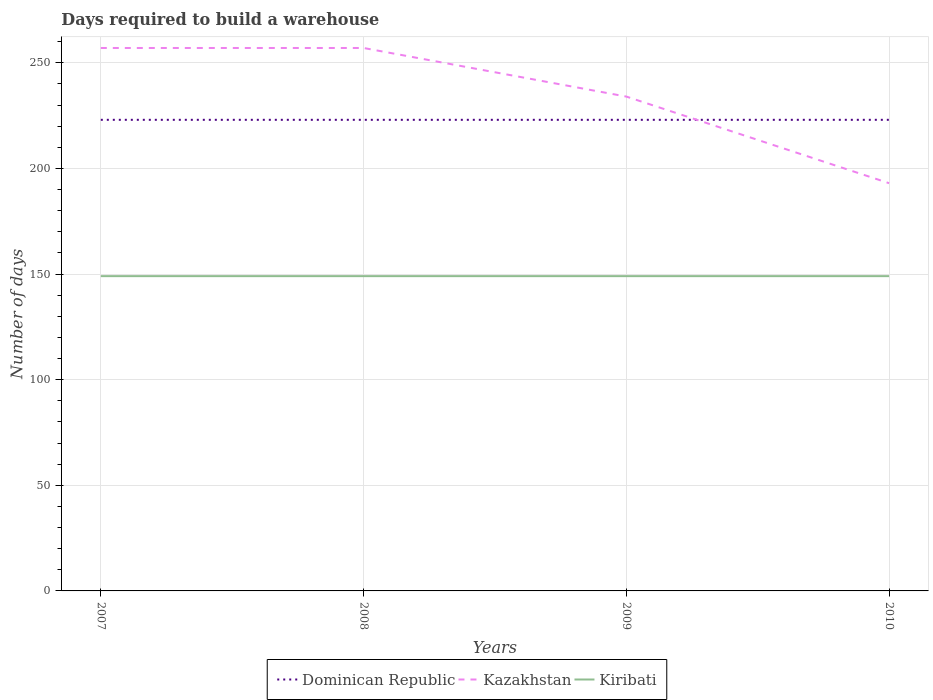Is the number of lines equal to the number of legend labels?
Provide a short and direct response. Yes. Across all years, what is the maximum days required to build a warehouse in in Kiribati?
Your answer should be compact. 149. In which year was the days required to build a warehouse in in Kazakhstan maximum?
Your answer should be compact. 2010. What is the total days required to build a warehouse in in Dominican Republic in the graph?
Your response must be concise. 0. What is the difference between the highest and the second highest days required to build a warehouse in in Kiribati?
Make the answer very short. 0. How many lines are there?
Offer a very short reply. 3. How many years are there in the graph?
Keep it short and to the point. 4. Does the graph contain grids?
Ensure brevity in your answer.  Yes. Where does the legend appear in the graph?
Provide a short and direct response. Bottom center. What is the title of the graph?
Your answer should be compact. Days required to build a warehouse. Does "Macao" appear as one of the legend labels in the graph?
Offer a terse response. No. What is the label or title of the X-axis?
Your answer should be very brief. Years. What is the label or title of the Y-axis?
Your answer should be compact. Number of days. What is the Number of days of Dominican Republic in 2007?
Provide a succinct answer. 223. What is the Number of days in Kazakhstan in 2007?
Your answer should be very brief. 257. What is the Number of days in Kiribati in 2007?
Your response must be concise. 149. What is the Number of days of Dominican Republic in 2008?
Provide a succinct answer. 223. What is the Number of days in Kazakhstan in 2008?
Give a very brief answer. 257. What is the Number of days in Kiribati in 2008?
Give a very brief answer. 149. What is the Number of days of Dominican Republic in 2009?
Give a very brief answer. 223. What is the Number of days in Kazakhstan in 2009?
Offer a very short reply. 234. What is the Number of days in Kiribati in 2009?
Provide a succinct answer. 149. What is the Number of days in Dominican Republic in 2010?
Make the answer very short. 223. What is the Number of days of Kazakhstan in 2010?
Provide a short and direct response. 193. What is the Number of days of Kiribati in 2010?
Provide a succinct answer. 149. Across all years, what is the maximum Number of days in Dominican Republic?
Your answer should be compact. 223. Across all years, what is the maximum Number of days of Kazakhstan?
Your answer should be very brief. 257. Across all years, what is the maximum Number of days in Kiribati?
Make the answer very short. 149. Across all years, what is the minimum Number of days of Dominican Republic?
Keep it short and to the point. 223. Across all years, what is the minimum Number of days of Kazakhstan?
Ensure brevity in your answer.  193. Across all years, what is the minimum Number of days of Kiribati?
Provide a succinct answer. 149. What is the total Number of days in Dominican Republic in the graph?
Provide a short and direct response. 892. What is the total Number of days of Kazakhstan in the graph?
Give a very brief answer. 941. What is the total Number of days in Kiribati in the graph?
Provide a short and direct response. 596. What is the difference between the Number of days of Dominican Republic in 2007 and that in 2008?
Provide a succinct answer. 0. What is the difference between the Number of days in Kazakhstan in 2007 and that in 2008?
Provide a succinct answer. 0. What is the difference between the Number of days in Kiribati in 2007 and that in 2008?
Your answer should be compact. 0. What is the difference between the Number of days of Dominican Republic in 2007 and that in 2009?
Your response must be concise. 0. What is the difference between the Number of days in Kiribati in 2007 and that in 2009?
Your answer should be compact. 0. What is the difference between the Number of days in Dominican Republic in 2008 and that in 2009?
Provide a short and direct response. 0. What is the difference between the Number of days of Kazakhstan in 2008 and that in 2009?
Keep it short and to the point. 23. What is the difference between the Number of days of Kazakhstan in 2008 and that in 2010?
Provide a short and direct response. 64. What is the difference between the Number of days of Dominican Republic in 2009 and that in 2010?
Give a very brief answer. 0. What is the difference between the Number of days of Kazakhstan in 2009 and that in 2010?
Offer a terse response. 41. What is the difference between the Number of days of Kiribati in 2009 and that in 2010?
Give a very brief answer. 0. What is the difference between the Number of days in Dominican Republic in 2007 and the Number of days in Kazakhstan in 2008?
Give a very brief answer. -34. What is the difference between the Number of days of Kazakhstan in 2007 and the Number of days of Kiribati in 2008?
Provide a short and direct response. 108. What is the difference between the Number of days of Dominican Republic in 2007 and the Number of days of Kazakhstan in 2009?
Make the answer very short. -11. What is the difference between the Number of days of Dominican Republic in 2007 and the Number of days of Kiribati in 2009?
Your answer should be very brief. 74. What is the difference between the Number of days of Kazakhstan in 2007 and the Number of days of Kiribati in 2009?
Offer a very short reply. 108. What is the difference between the Number of days of Dominican Republic in 2007 and the Number of days of Kazakhstan in 2010?
Provide a short and direct response. 30. What is the difference between the Number of days in Dominican Republic in 2007 and the Number of days in Kiribati in 2010?
Provide a succinct answer. 74. What is the difference between the Number of days in Kazakhstan in 2007 and the Number of days in Kiribati in 2010?
Your response must be concise. 108. What is the difference between the Number of days in Kazakhstan in 2008 and the Number of days in Kiribati in 2009?
Offer a terse response. 108. What is the difference between the Number of days of Dominican Republic in 2008 and the Number of days of Kazakhstan in 2010?
Keep it short and to the point. 30. What is the difference between the Number of days in Dominican Republic in 2008 and the Number of days in Kiribati in 2010?
Offer a very short reply. 74. What is the difference between the Number of days in Kazakhstan in 2008 and the Number of days in Kiribati in 2010?
Your answer should be compact. 108. What is the difference between the Number of days in Dominican Republic in 2009 and the Number of days in Kazakhstan in 2010?
Offer a terse response. 30. What is the average Number of days of Dominican Republic per year?
Your answer should be very brief. 223. What is the average Number of days of Kazakhstan per year?
Offer a very short reply. 235.25. What is the average Number of days in Kiribati per year?
Your answer should be very brief. 149. In the year 2007, what is the difference between the Number of days of Dominican Republic and Number of days of Kazakhstan?
Ensure brevity in your answer.  -34. In the year 2007, what is the difference between the Number of days of Kazakhstan and Number of days of Kiribati?
Provide a short and direct response. 108. In the year 2008, what is the difference between the Number of days in Dominican Republic and Number of days in Kazakhstan?
Offer a very short reply. -34. In the year 2008, what is the difference between the Number of days in Dominican Republic and Number of days in Kiribati?
Your response must be concise. 74. In the year 2008, what is the difference between the Number of days in Kazakhstan and Number of days in Kiribati?
Provide a succinct answer. 108. In the year 2009, what is the difference between the Number of days in Dominican Republic and Number of days in Kazakhstan?
Give a very brief answer. -11. In the year 2009, what is the difference between the Number of days in Kazakhstan and Number of days in Kiribati?
Give a very brief answer. 85. What is the ratio of the Number of days in Dominican Republic in 2007 to that in 2008?
Provide a succinct answer. 1. What is the ratio of the Number of days in Kazakhstan in 2007 to that in 2008?
Your answer should be very brief. 1. What is the ratio of the Number of days in Dominican Republic in 2007 to that in 2009?
Keep it short and to the point. 1. What is the ratio of the Number of days in Kazakhstan in 2007 to that in 2009?
Offer a terse response. 1.1. What is the ratio of the Number of days in Kazakhstan in 2007 to that in 2010?
Your response must be concise. 1.33. What is the ratio of the Number of days in Kazakhstan in 2008 to that in 2009?
Your answer should be very brief. 1.1. What is the ratio of the Number of days of Dominican Republic in 2008 to that in 2010?
Provide a succinct answer. 1. What is the ratio of the Number of days of Kazakhstan in 2008 to that in 2010?
Provide a short and direct response. 1.33. What is the ratio of the Number of days in Kiribati in 2008 to that in 2010?
Make the answer very short. 1. What is the ratio of the Number of days of Dominican Republic in 2009 to that in 2010?
Provide a succinct answer. 1. What is the ratio of the Number of days in Kazakhstan in 2009 to that in 2010?
Make the answer very short. 1.21. What is the difference between the highest and the second highest Number of days in Kiribati?
Ensure brevity in your answer.  0. 